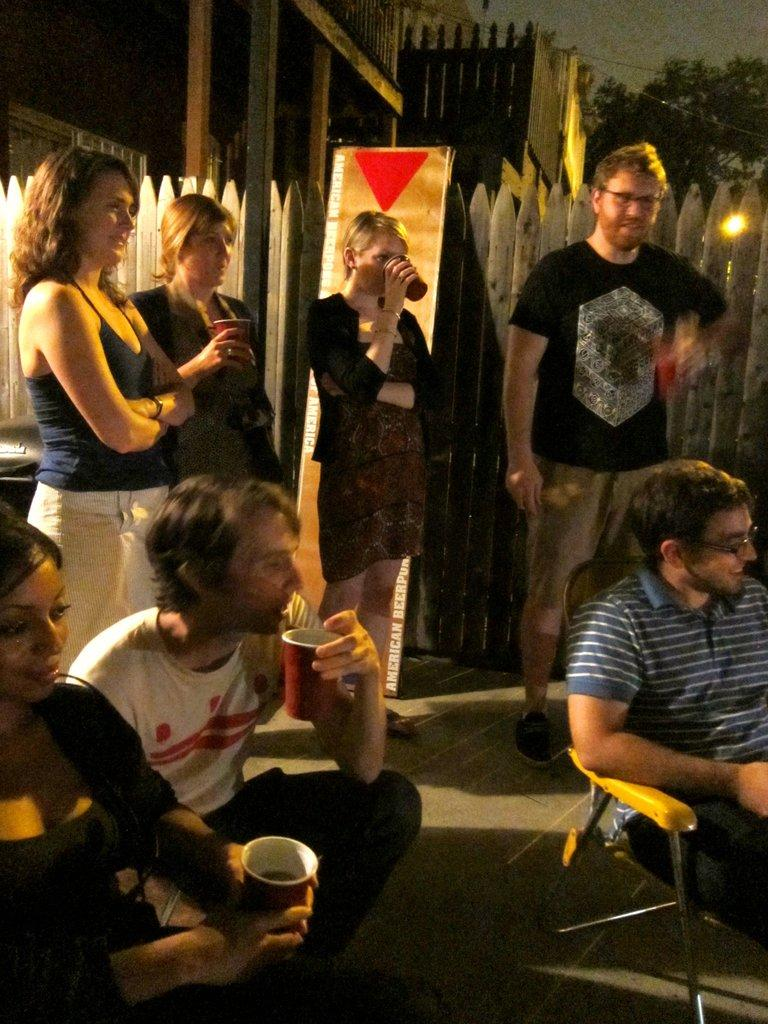How many people are in the image? There are people in the image, but the exact number is not specified. What are some of the people doing in the image? Some of the people are sitting, and some are holding glasses. What can be seen in the background of the image? There is a tree and wooden fencing in the image. What type of milk can be seen in the image? There is no mention of milk in the image. 